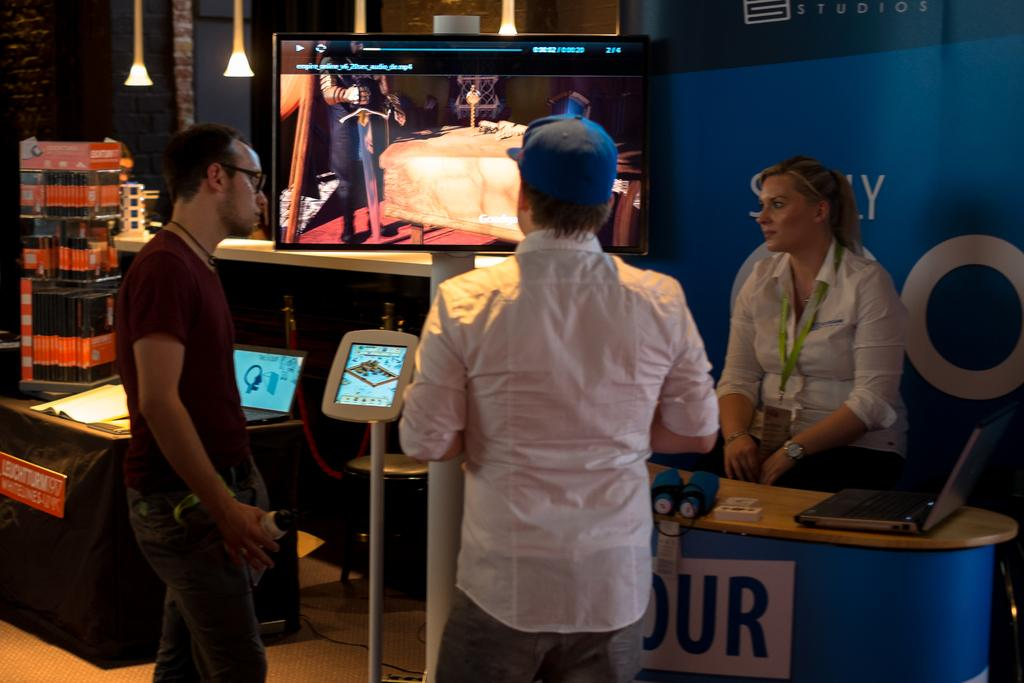Where was the image taken? The image was taken in a room. How many people are in the image? There are three persons standing in the room. What is the surface that the people are standing on? The people are standing on a floor. What is in front of the people in the image? There is a television in front of the people. What is visible behind the people in the image? There is a banner behind the people. Can you see any planes flying over the bridge in the image? There is no bridge or planes visible in the image; it is taken in a room with three people standing in front of a television and a banner. 